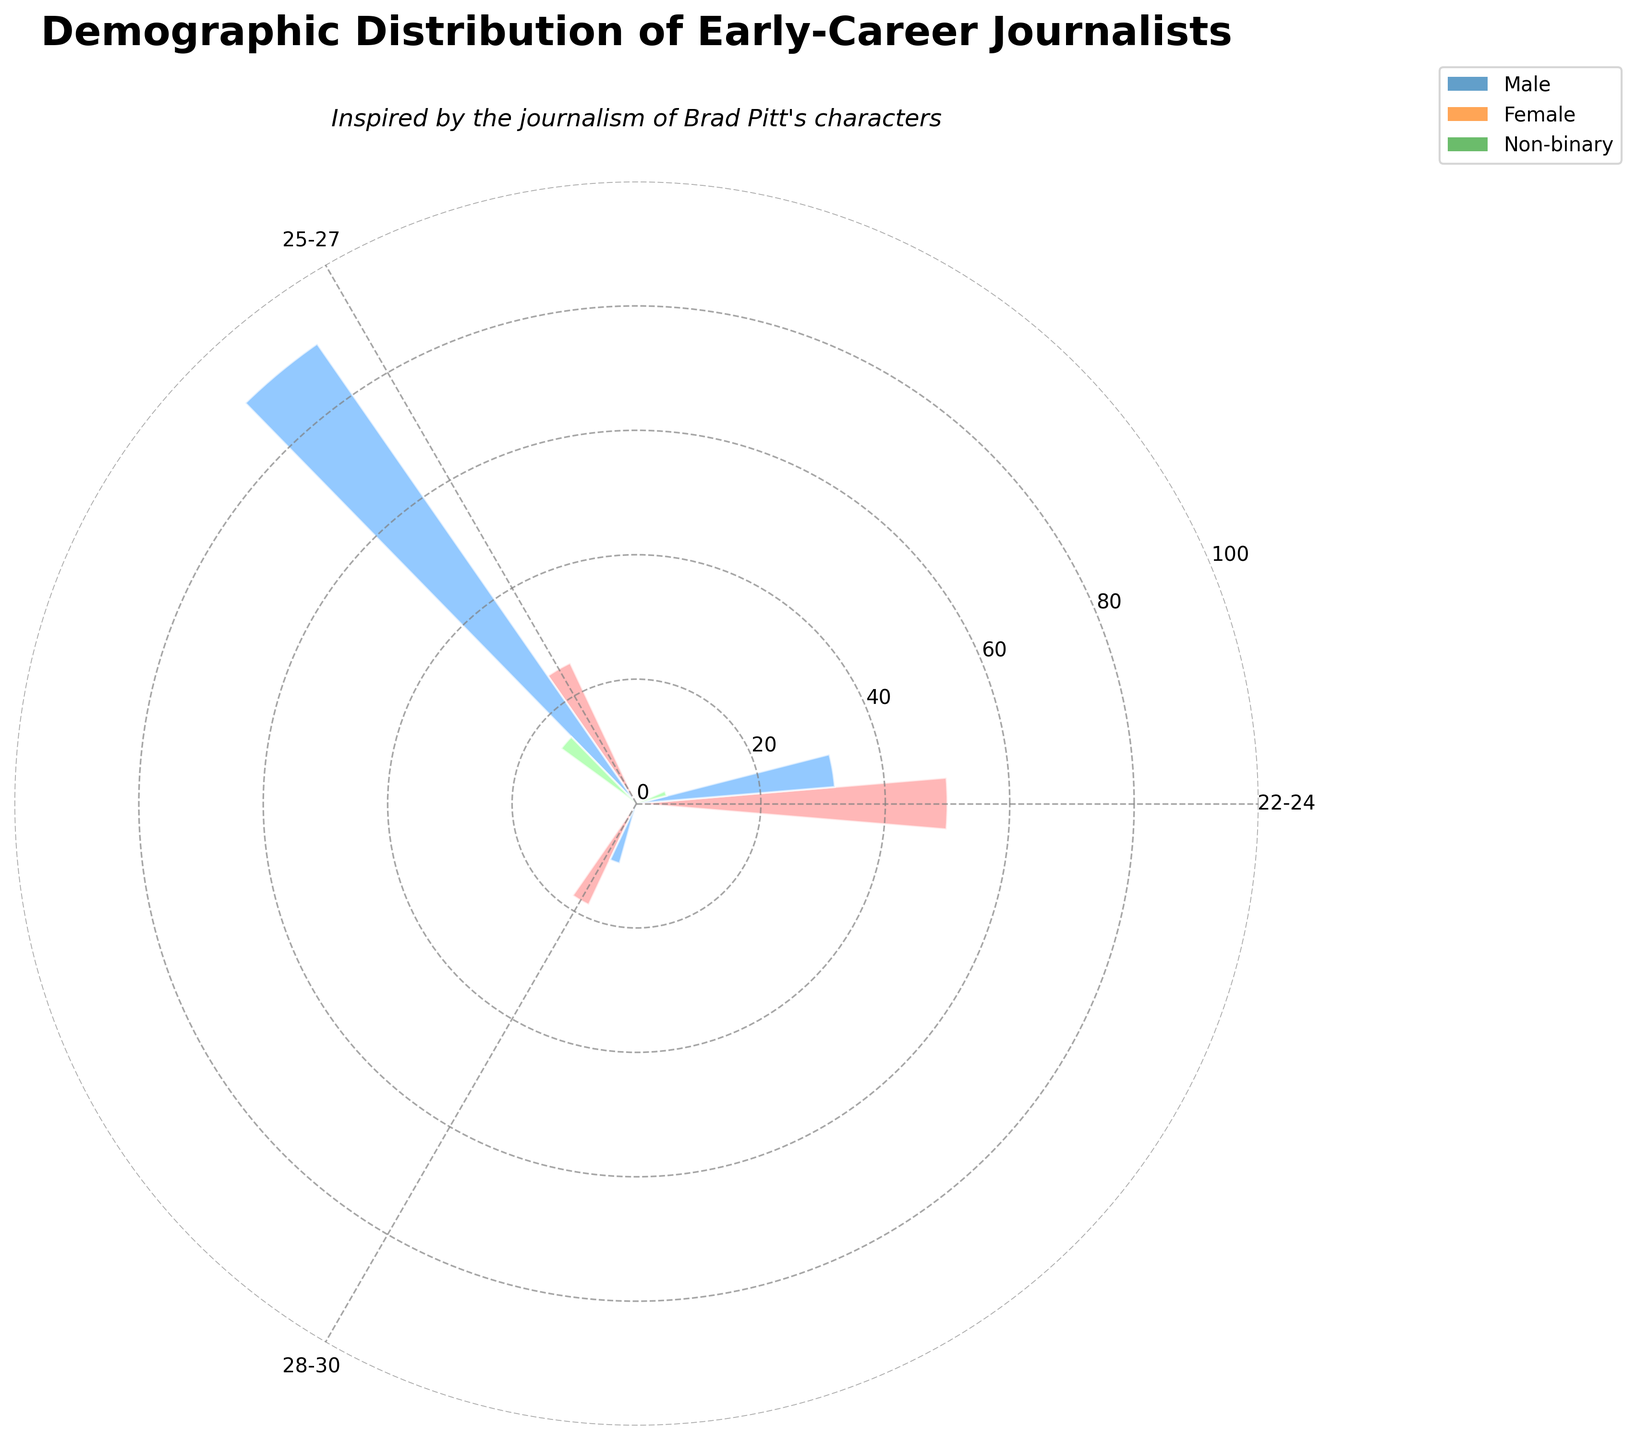What is the title of the chart? The title of the chart is placed at the top of the figure and sets the context for what the visualization represents.
Answer: Demographic Distribution of Early-Career Journalists How many different age categories are present in the chart? The radial axis (angles) of the rose chart shows different age categories. Counting the unique labels on the angles will give the number of age categories.
Answer: 3 Which gender has the highest representation in the 25-27 age category? Look for the bars corresponding to the 25-27 age category and compare their heights for each gender.
Answer: Female What is the total count of early-career journalists with a Master's Degree? Sum the counts from all gender and age groups that mention a "Master's Degree" in the Education Level.
Answer: 70 Which age group shows the highest count of journalists? Compare the total heights of bars in each age category to identify the one with the highest aggregate count.
Answer: 25-27 In which age category do non-binary journalists have a representation? Identify the bars associated with non-binary gender and observe which age categories they fall into.
Answer: 22-24 and 28-30 Between males and females, who has a higher representation in the 22-24 age group? Compare the heights of the bars associated with males and females within the 22-24 age group.
Answer: Male What is the average count of female journalists across all age groups? Sum the heights of the bars representing females across all age groups and divide by the number of age groups.
Answer: 30 Does any age group have an equal representation of male and female journalists? Compare the heights of male and female bars within each age category to check for equality.
Answer: No How does the representation of journalists with an Associate's Degree compare between 22-24 and 25-27 age groups? Compare the height of the bars for the Associate's Degree in the 22-24 and 25-27 age groups.
Answer: Higher in 25-27 